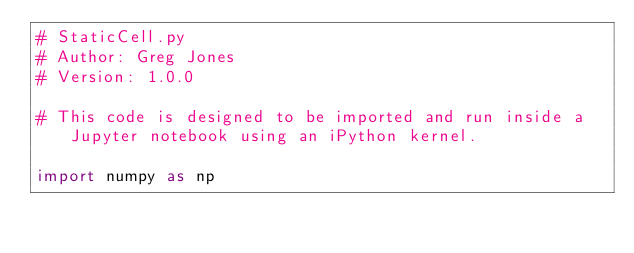<code> <loc_0><loc_0><loc_500><loc_500><_Python_># StaticCell.py
# Author: Greg Jones
# Version: 1.0.0

# This code is designed to be imported and run inside a Jupyter notebook using an iPython kernel.

import numpy as np</code> 